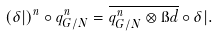Convert formula to latex. <formula><loc_0><loc_0><loc_500><loc_500>( \delta | ) ^ { n } \circ q ^ { n } _ { G / N } = \overline { q ^ { n } _ { G / N } \otimes \i d } \circ \delta | .</formula> 